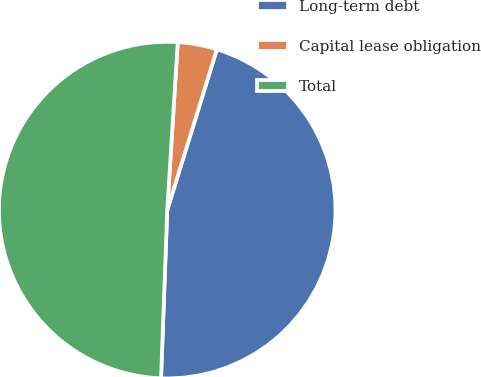Convert chart. <chart><loc_0><loc_0><loc_500><loc_500><pie_chart><fcel>Long-term debt<fcel>Capital lease obligation<fcel>Total<nl><fcel>45.82%<fcel>3.77%<fcel>50.41%<nl></chart> 